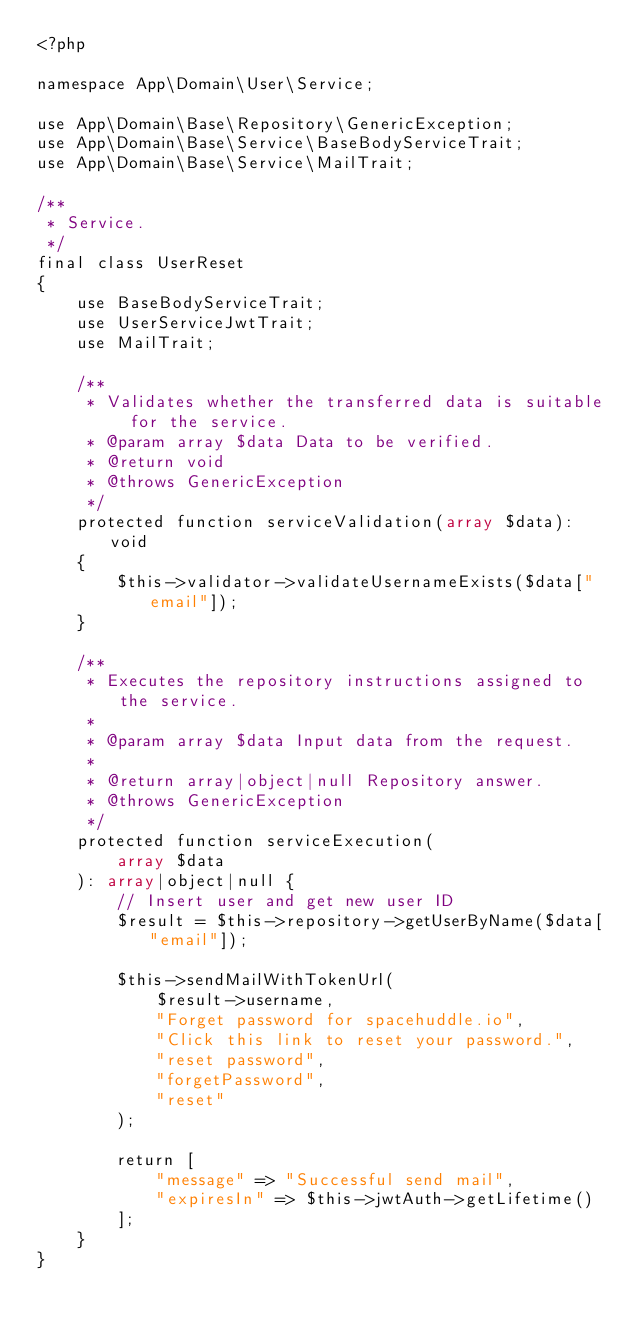Convert code to text. <code><loc_0><loc_0><loc_500><loc_500><_PHP_><?php

namespace App\Domain\User\Service;

use App\Domain\Base\Repository\GenericException;
use App\Domain\Base\Service\BaseBodyServiceTrait;
use App\Domain\Base\Service\MailTrait;

/**
 * Service.
 */
final class UserReset
{
    use BaseBodyServiceTrait;
    use UserServiceJwtTrait;
    use MailTrait;

    /**
     * Validates whether the transferred data is suitable for the service.
     * @param array $data Data to be verified.
     * @return void
     * @throws GenericException
     */
    protected function serviceValidation(array $data): void
    {
        $this->validator->validateUsernameExists($data["email"]);
    }

    /**
     * Executes the repository instructions assigned to the service.
     *
     * @param array $data Input data from the request.
     *
     * @return array|object|null Repository answer.
     * @throws GenericException
     */
    protected function serviceExecution(
        array $data
    ): array|object|null {
        // Insert user and get new user ID
        $result = $this->repository->getUserByName($data["email"]);

        $this->sendMailWithTokenUrl(
            $result->username,
            "Forget password for spacehuddle.io",
            "Click this link to reset your password.",
            "reset password",
            "forgetPassword",
            "reset"
        );

        return [
            "message" => "Successful send mail",
            "expiresIn" => $this->jwtAuth->getLifetime()
        ];
    }
}
</code> 